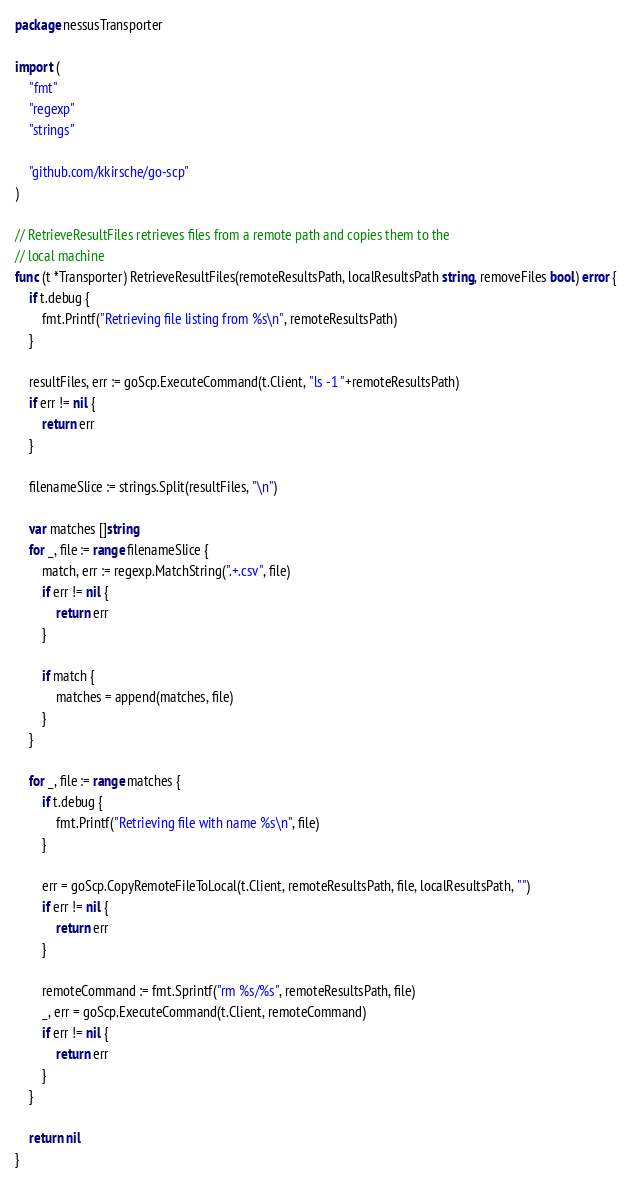<code> <loc_0><loc_0><loc_500><loc_500><_Go_>package nessusTransporter

import (
	"fmt"
	"regexp"
	"strings"

	"github.com/kkirsche/go-scp"
)

// RetrieveResultFiles retrieves files from a remote path and copies them to the
// local machine
func (t *Transporter) RetrieveResultFiles(remoteResultsPath, localResultsPath string, removeFiles bool) error {
	if t.debug {
		fmt.Printf("Retrieving file listing from %s\n", remoteResultsPath)
	}

	resultFiles, err := goScp.ExecuteCommand(t.Client, "ls -1 "+remoteResultsPath)
	if err != nil {
		return err
	}

	filenameSlice := strings.Split(resultFiles, "\n")

	var matches []string
	for _, file := range filenameSlice {
		match, err := regexp.MatchString(".+.csv", file)
		if err != nil {
			return err
		}

		if match {
			matches = append(matches, file)
		}
	}

	for _, file := range matches {
		if t.debug {
			fmt.Printf("Retrieving file with name %s\n", file)
		}

		err = goScp.CopyRemoteFileToLocal(t.Client, remoteResultsPath, file, localResultsPath, "")
		if err != nil {
			return err
		}

		remoteCommand := fmt.Sprintf("rm %s/%s", remoteResultsPath, file)
		_, err = goScp.ExecuteCommand(t.Client, remoteCommand)
		if err != nil {
			return err
		}
	}

	return nil
}
</code> 